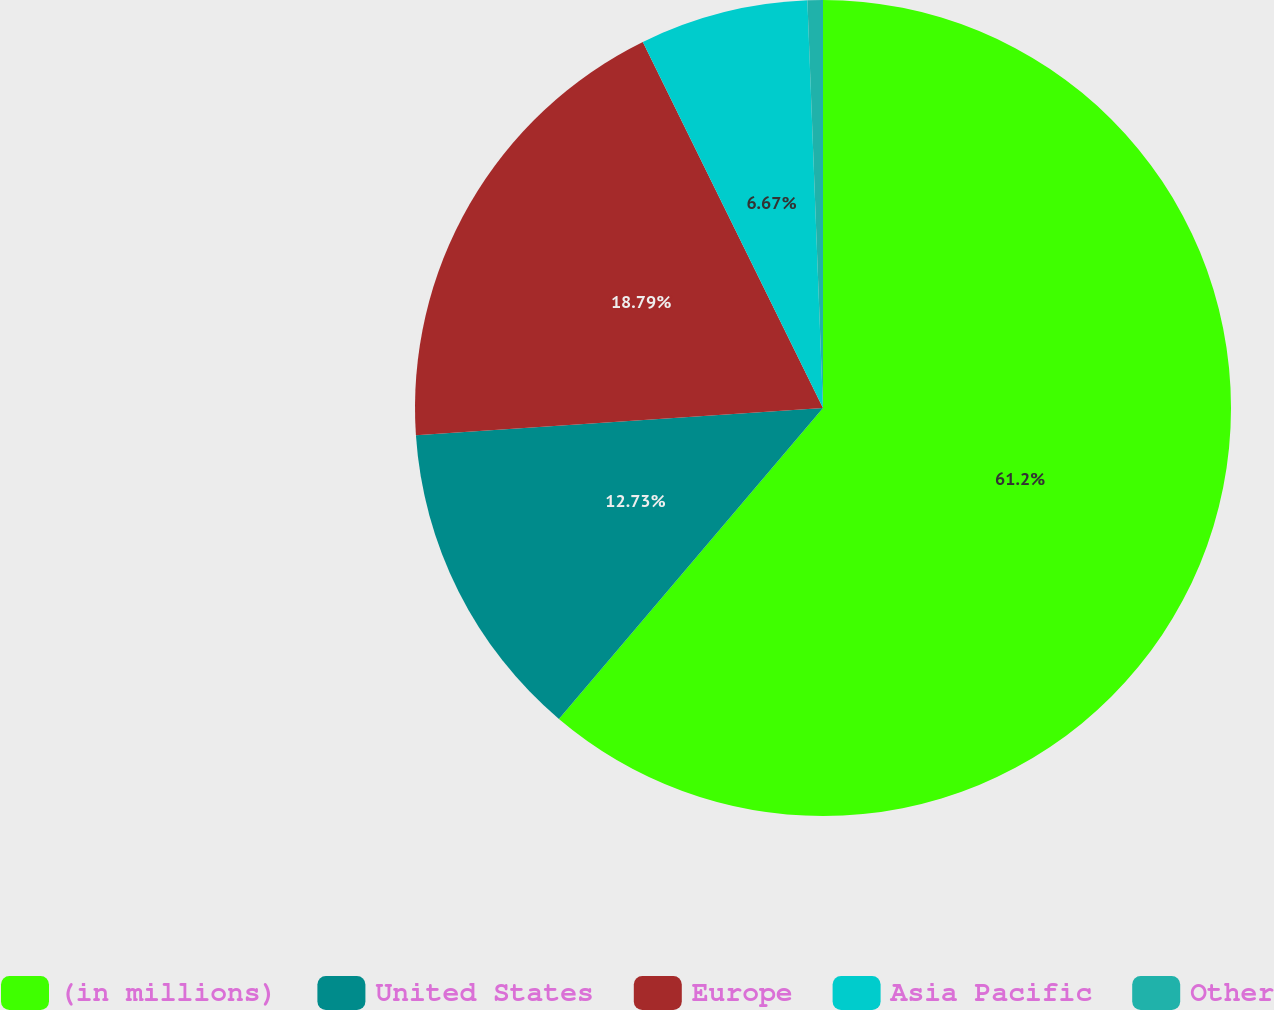<chart> <loc_0><loc_0><loc_500><loc_500><pie_chart><fcel>(in millions)<fcel>United States<fcel>Europe<fcel>Asia Pacific<fcel>Other<nl><fcel>61.21%<fcel>12.73%<fcel>18.79%<fcel>6.67%<fcel>0.61%<nl></chart> 